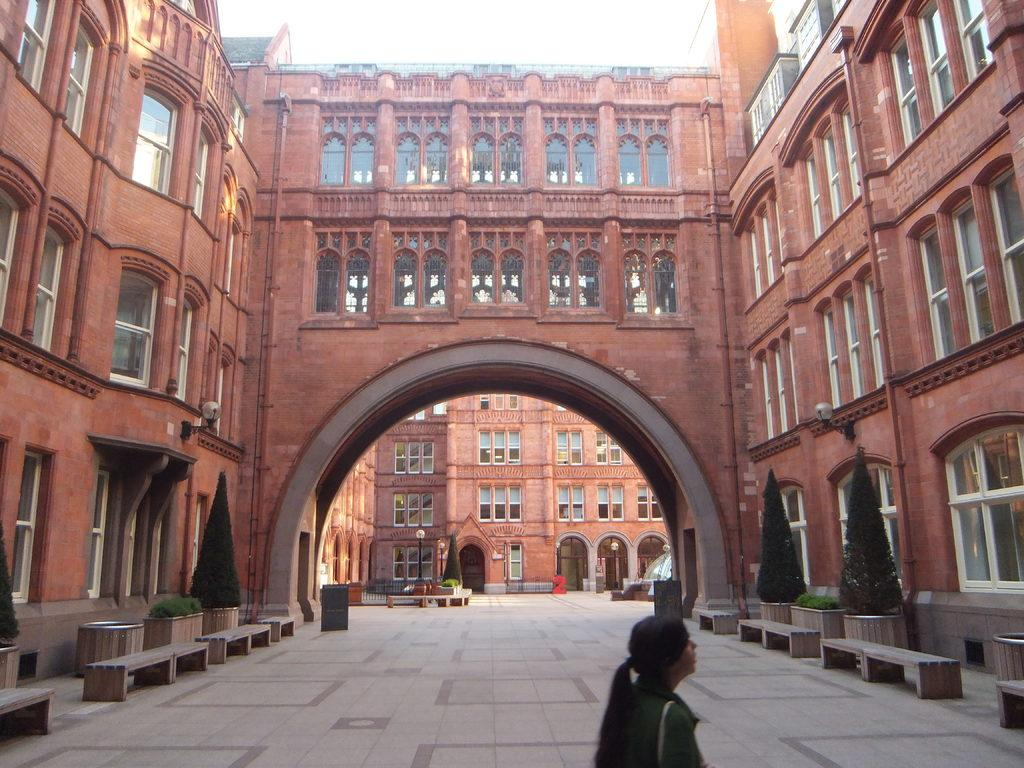What type of structures can be seen in the image? There are buildings in the image. What else can be seen in the image besides the buildings? There are lights, shrubs, plants, benches, and a lady wearing a bag in the image. Can you describe the floor in the image? There is a floor at the bottom of the image. Where is the meeting taking place in the image? There is no meeting depicted in the image. What type of wind can be seen blowing in the image? There is no wind or zephyr present in the image. 